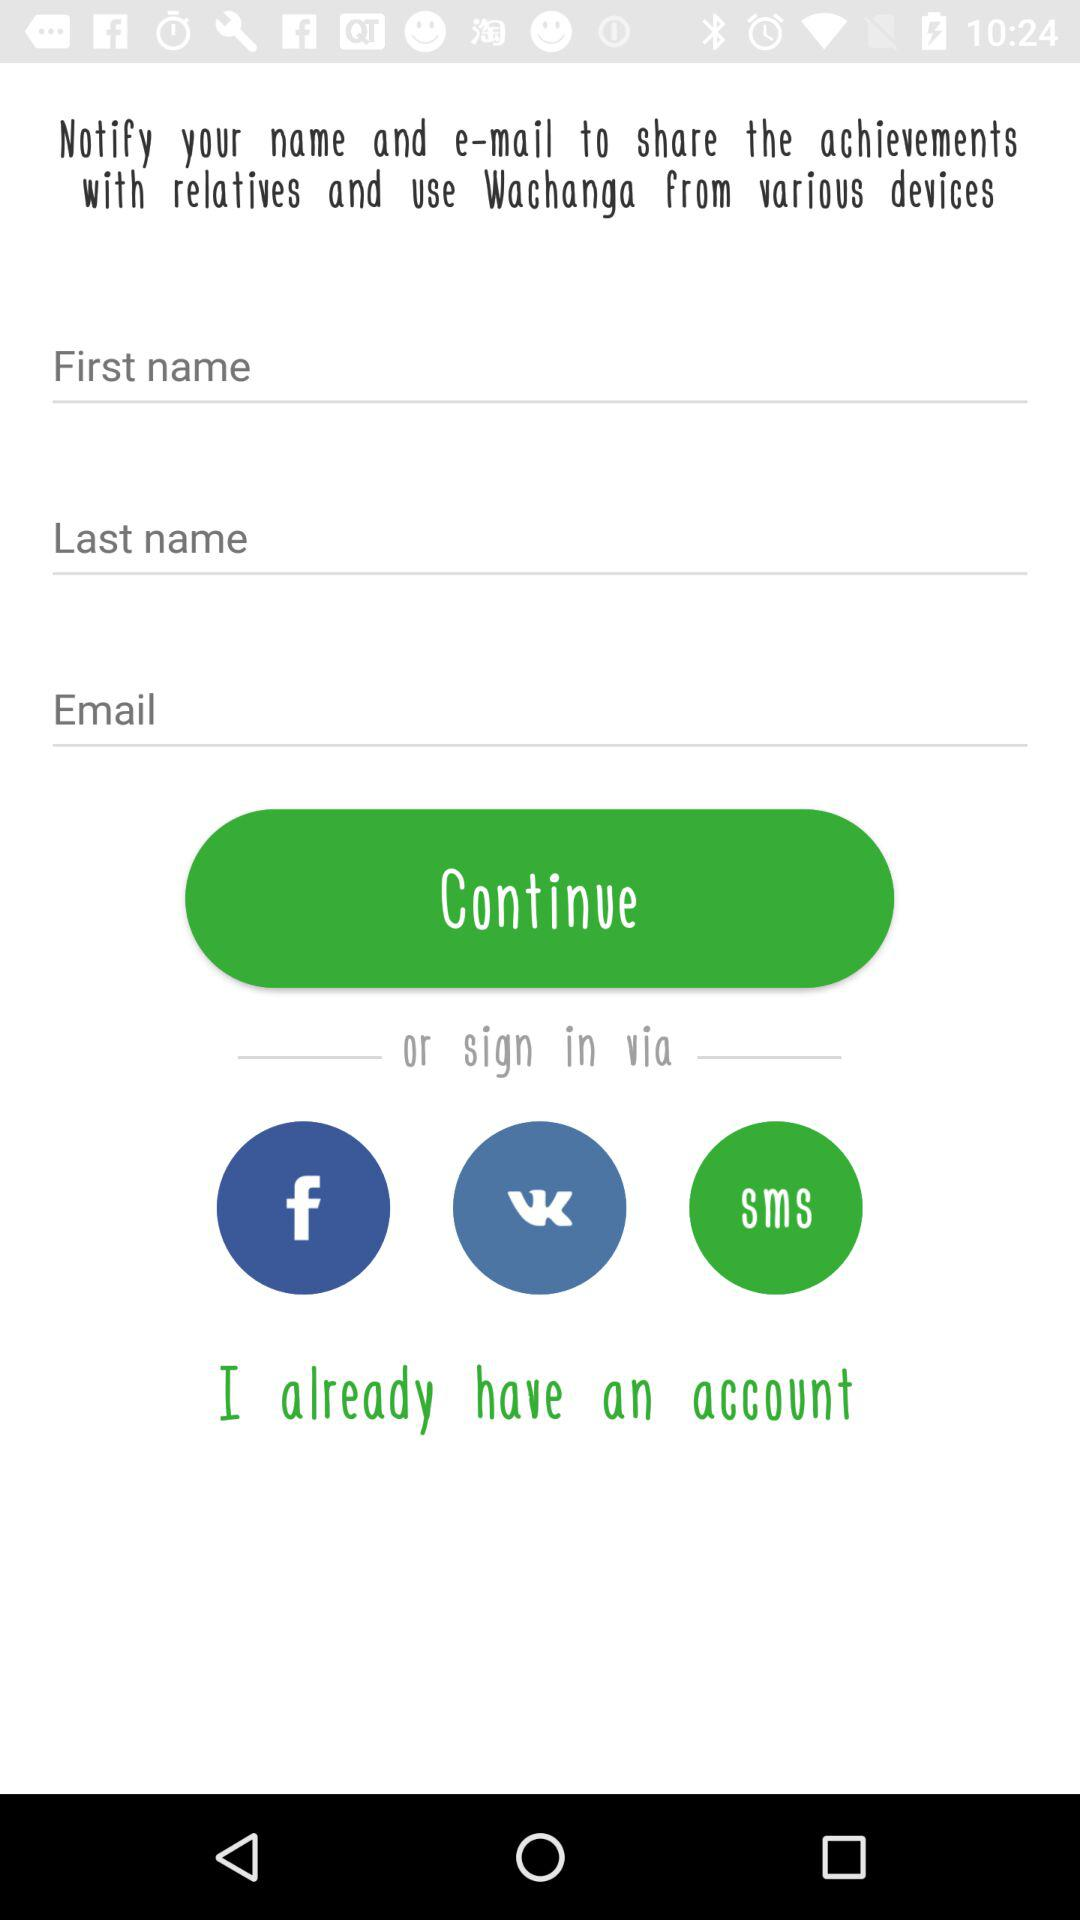How many text inputs are there that require the user to enter their name?
Answer the question using a single word or phrase. 2 